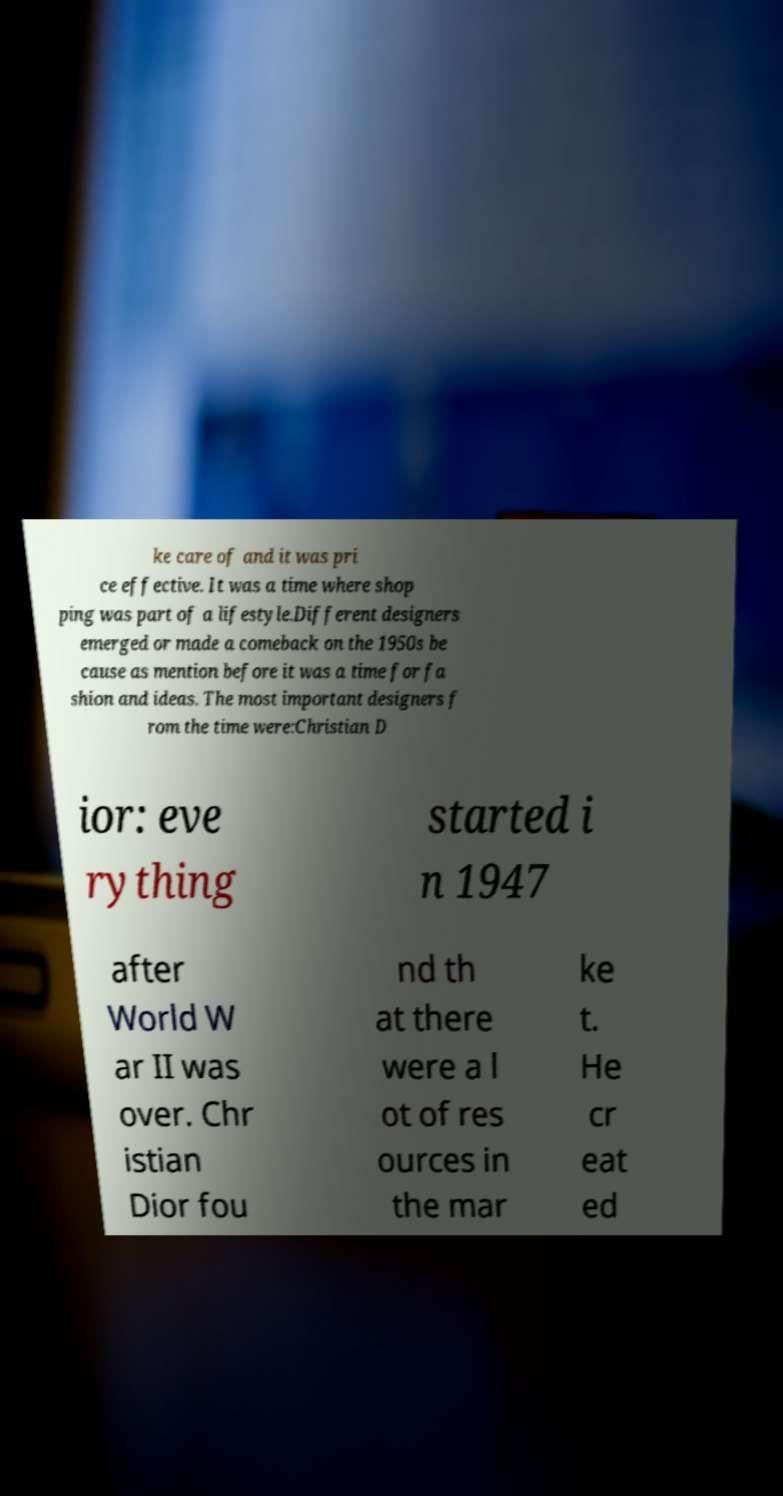What messages or text are displayed in this image? I need them in a readable, typed format. ke care of and it was pri ce effective. It was a time where shop ping was part of a lifestyle.Different designers emerged or made a comeback on the 1950s be cause as mention before it was a time for fa shion and ideas. The most important designers f rom the time were:Christian D ior: eve rything started i n 1947 after World W ar II was over. Chr istian Dior fou nd th at there were a l ot of res ources in the mar ke t. He cr eat ed 